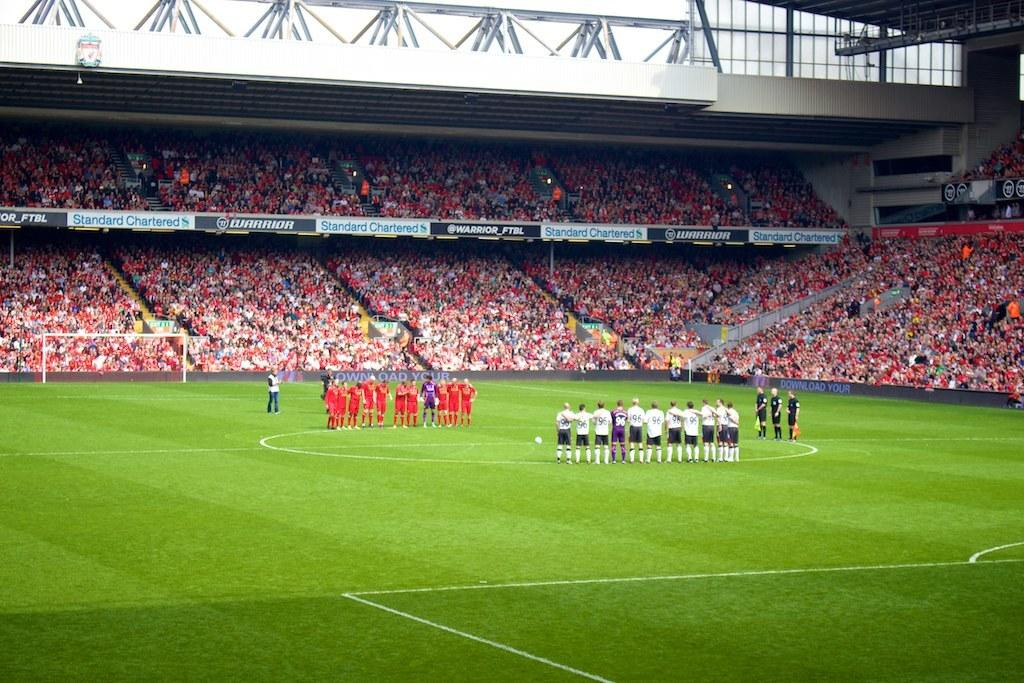<image>
Summarize the visual content of the image. Two spoorts teams stand on a large soccer field surrounded by banner advertisements for Standard Charter and WARRIOR 